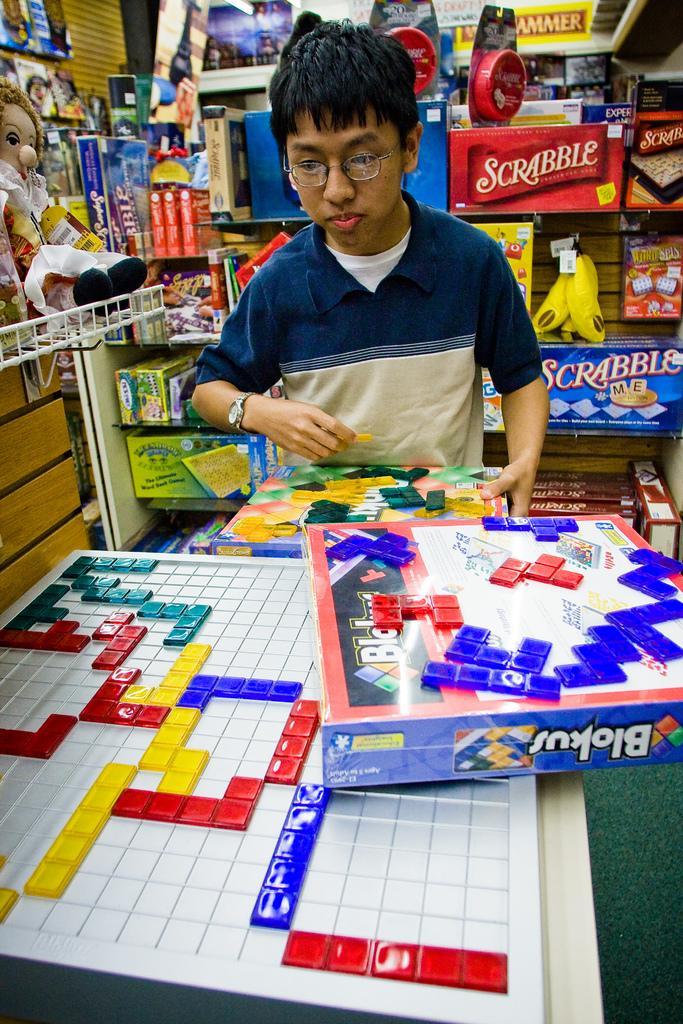In one or two sentences, can you explain what this image depicts? In this image in the center there is one boy who is standing, and he is holding some box. And in the background there some dolls, boxes, packets and some other objects. In the foreground there is one board and a box, at the bottom there is floor. 